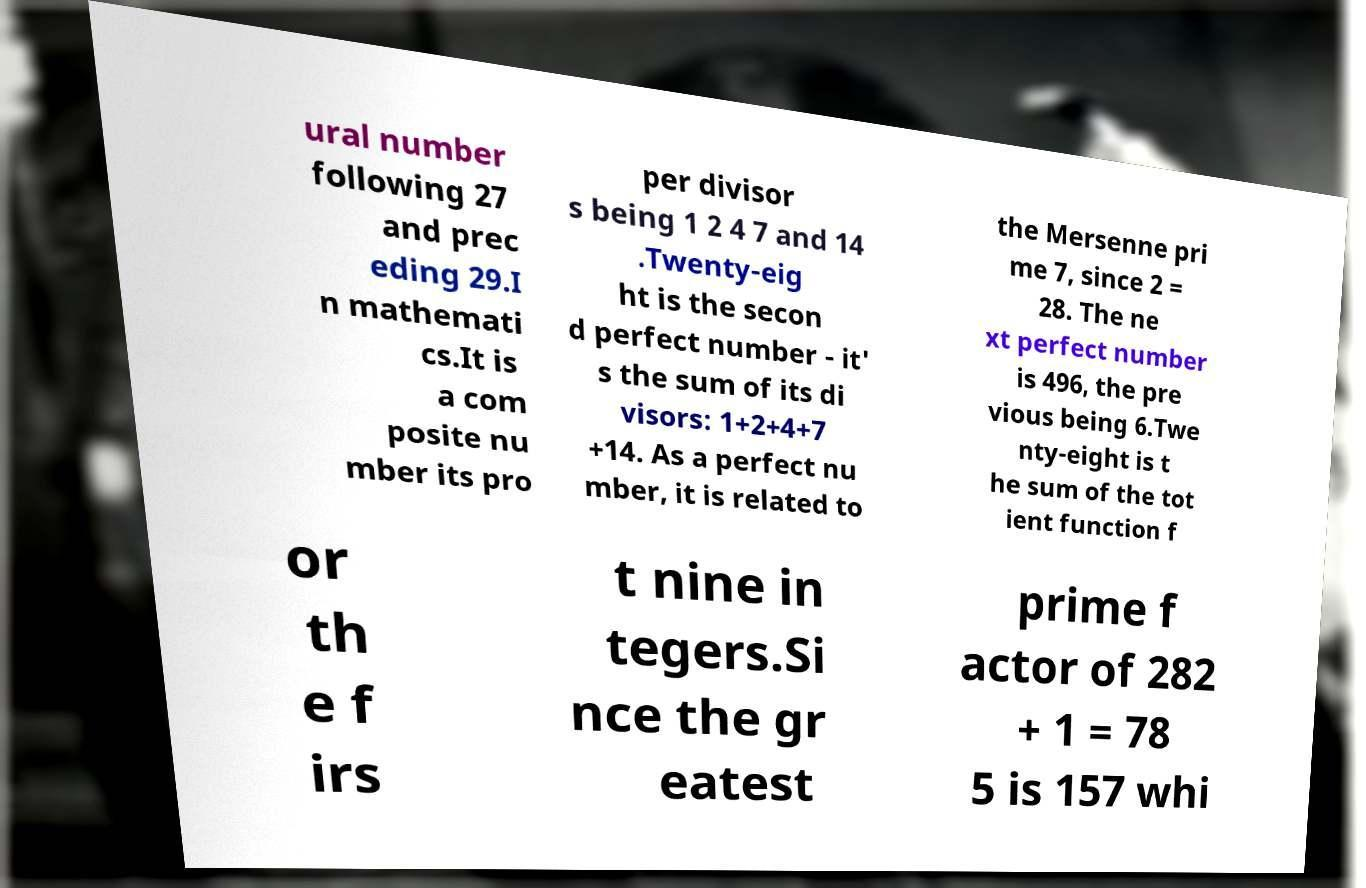Can you read and provide the text displayed in the image?This photo seems to have some interesting text. Can you extract and type it out for me? ural number following 27 and prec eding 29.I n mathemati cs.It is a com posite nu mber its pro per divisor s being 1 2 4 7 and 14 .Twenty-eig ht is the secon d perfect number - it' s the sum of its di visors: 1+2+4+7 +14. As a perfect nu mber, it is related to the Mersenne pri me 7, since 2 = 28. The ne xt perfect number is 496, the pre vious being 6.Twe nty-eight is t he sum of the tot ient function f or th e f irs t nine in tegers.Si nce the gr eatest prime f actor of 282 + 1 = 78 5 is 157 whi 